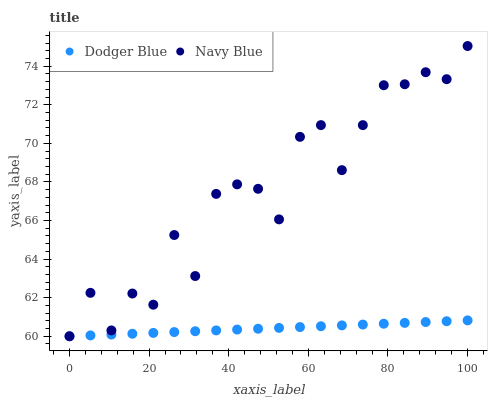Does Dodger Blue have the minimum area under the curve?
Answer yes or no. Yes. Does Navy Blue have the maximum area under the curve?
Answer yes or no. Yes. Does Dodger Blue have the maximum area under the curve?
Answer yes or no. No. Is Dodger Blue the smoothest?
Answer yes or no. Yes. Is Navy Blue the roughest?
Answer yes or no. Yes. Is Dodger Blue the roughest?
Answer yes or no. No. Does Navy Blue have the lowest value?
Answer yes or no. Yes. Does Navy Blue have the highest value?
Answer yes or no. Yes. Does Dodger Blue have the highest value?
Answer yes or no. No. Does Dodger Blue intersect Navy Blue?
Answer yes or no. Yes. Is Dodger Blue less than Navy Blue?
Answer yes or no. No. Is Dodger Blue greater than Navy Blue?
Answer yes or no. No. 